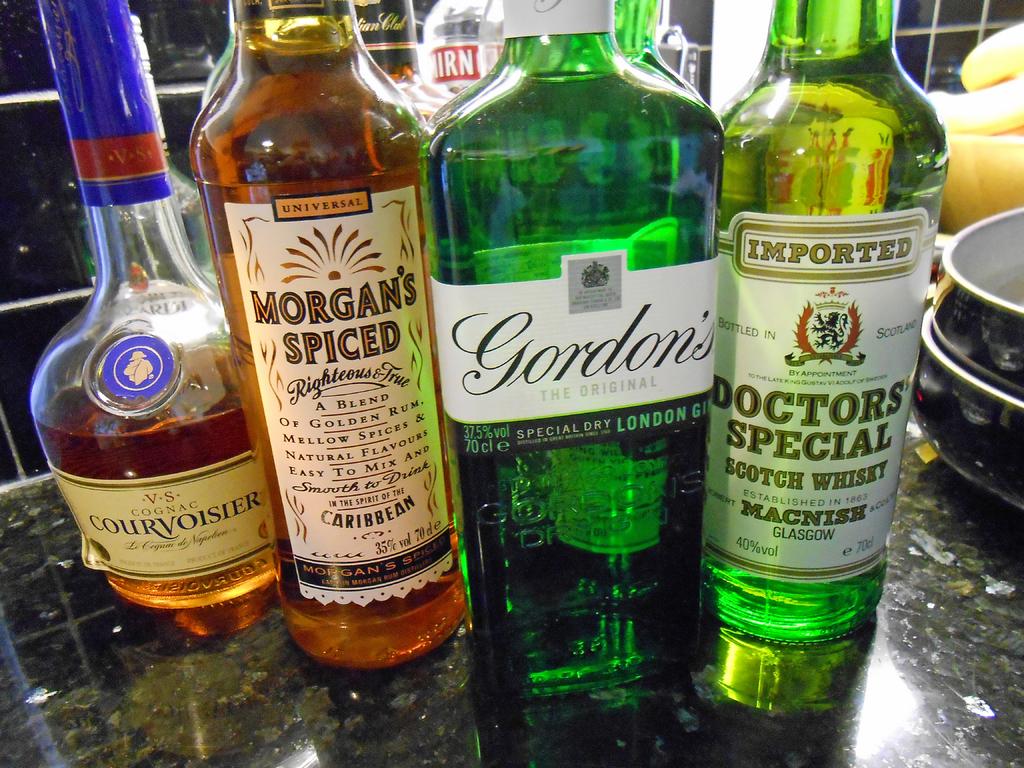What kind of alcohol is the doctors special?
Make the answer very short. Scotch whisky. 